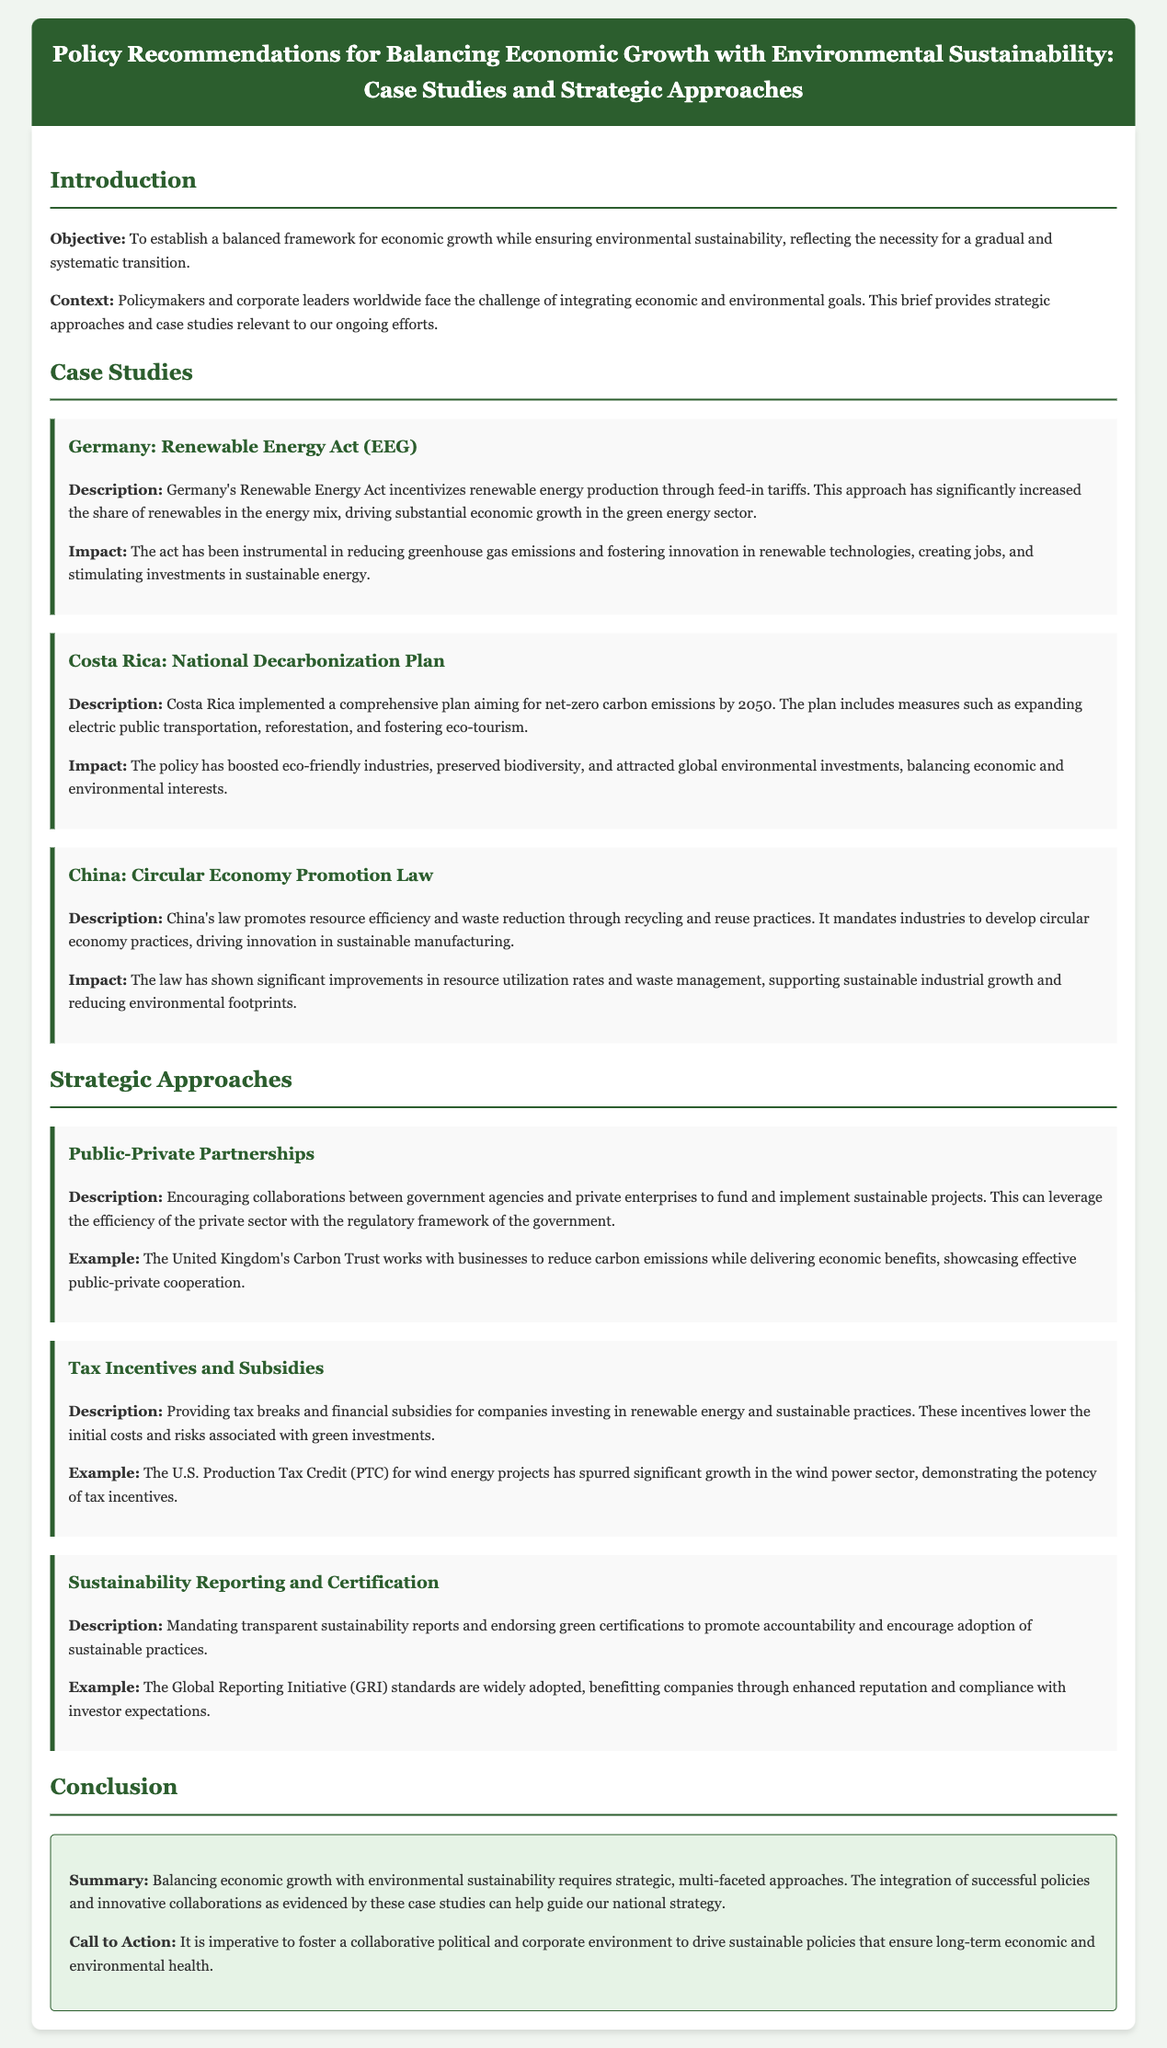What is the objective of the brief? The objective is to establish a balanced framework for economic growth while ensuring environmental sustainability.
Answer: Balanced framework for economic growth and environmental sustainability Which country implemented the National Decarbonization Plan? Costa Rica is the country that implemented this plan aiming for net-zero carbon emissions by 2050.
Answer: Costa Rica What does China’s Circular Economy Promotion Law promote? It promotes resource efficiency and waste reduction through recycling and reuse practices.
Answer: Resource efficiency and waste reduction What type of partnerships are encouraged in the strategic approaches? Public-Private Partnerships are encouraged to fund and implement sustainable projects.
Answer: Public-Private Partnerships What is one example of a tax incentive mentioned in the document? The U.S. Production Tax Credit for wind energy projects is one example of a tax incentive.
Answer: U.S. Production Tax Credit How has Germany’s Renewable Energy Act impacted greenhouse gas emissions? The act has been instrumental in reducing greenhouse gas emissions.
Answer: Reducing greenhouse gas emissions What framework is suggested for encouraging accountability in sustainable practices? Mandating transparent sustainability reports and endorsing green certifications promotes accountability.
Answer: Sustainability reports and green certifications What should be fostered to drive sustainable policies? A collaborative political and corporate environment should be fostered.
Answer: Collaborative political and corporate environment 